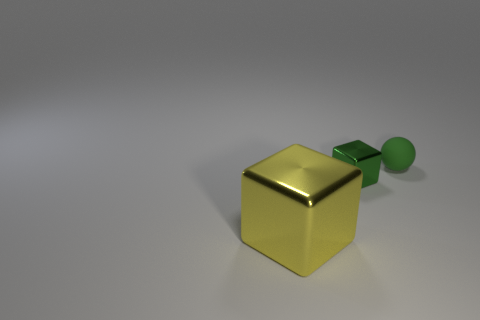Subtract all green blocks. How many blocks are left? 1 Add 2 big yellow metallic blocks. How many objects exist? 5 Subtract all balls. How many objects are left? 2 Add 2 green cubes. How many green cubes exist? 3 Subtract 0 purple balls. How many objects are left? 3 Subtract all purple balls. Subtract all brown cylinders. How many balls are left? 1 Subtract all gray spheres. How many yellow blocks are left? 1 Subtract all yellow shiny cubes. Subtract all small blocks. How many objects are left? 1 Add 3 large things. How many large things are left? 4 